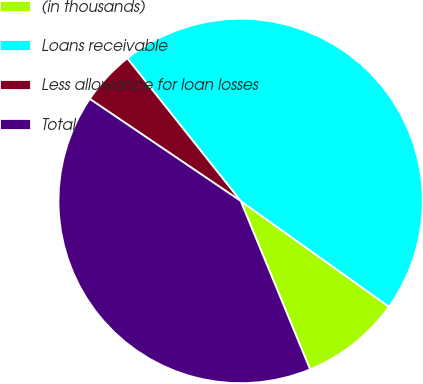<chart> <loc_0><loc_0><loc_500><loc_500><pie_chart><fcel>(in thousands)<fcel>Loans receivable<fcel>Less allowance for loan losses<fcel>Total<nl><fcel>8.92%<fcel>45.54%<fcel>4.85%<fcel>40.69%<nl></chart> 